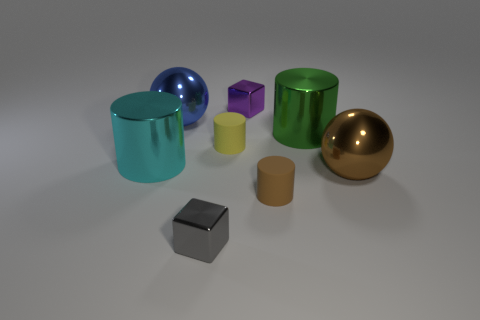Subtract all gray cylinders. Subtract all purple cubes. How many cylinders are left? 4 Add 1 cubes. How many objects exist? 9 Subtract all spheres. How many objects are left? 6 Add 5 shiny balls. How many shiny balls are left? 7 Add 6 tiny yellow rubber spheres. How many tiny yellow rubber spheres exist? 6 Subtract 0 red cylinders. How many objects are left? 8 Subtract all big brown shiny spheres. Subtract all big blue things. How many objects are left? 6 